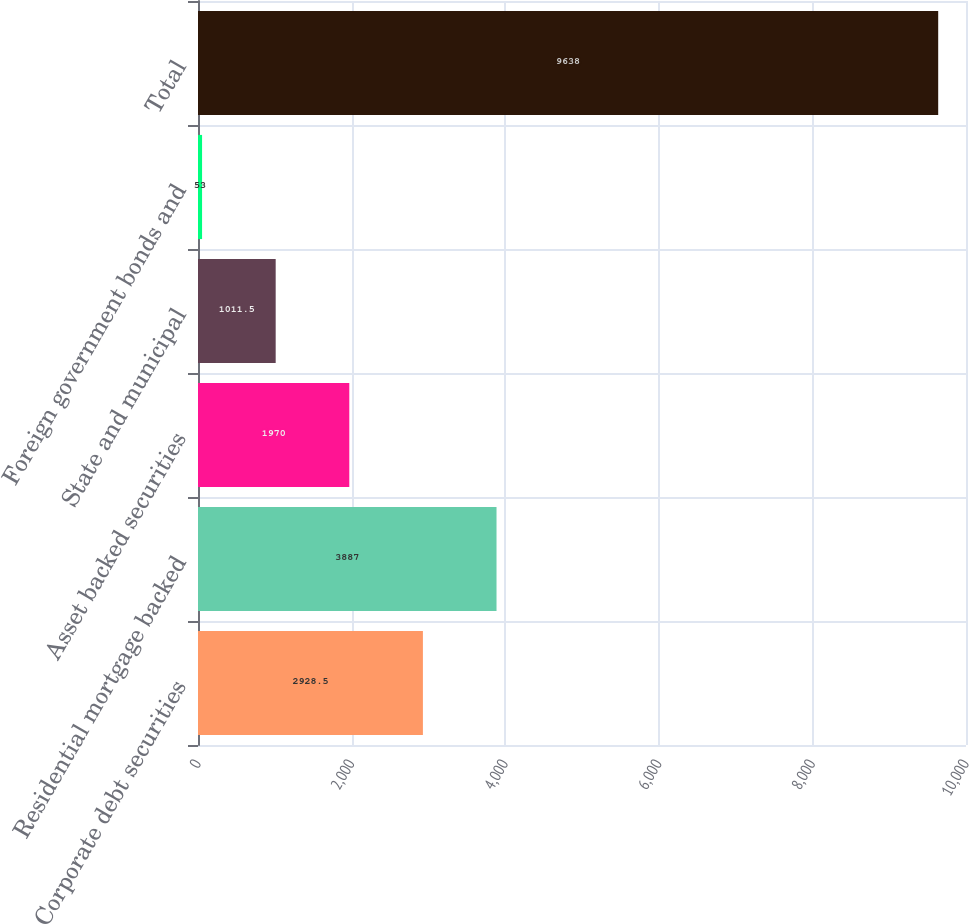Convert chart. <chart><loc_0><loc_0><loc_500><loc_500><bar_chart><fcel>Corporate debt securities<fcel>Residential mortgage backed<fcel>Asset backed securities<fcel>State and municipal<fcel>Foreign government bonds and<fcel>Total<nl><fcel>2928.5<fcel>3887<fcel>1970<fcel>1011.5<fcel>53<fcel>9638<nl></chart> 